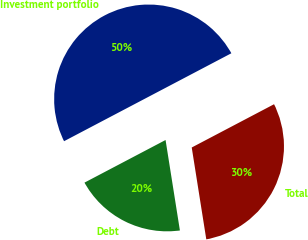Convert chart to OTSL. <chart><loc_0><loc_0><loc_500><loc_500><pie_chart><fcel>Investment portfolio<fcel>Debt<fcel>Total<nl><fcel>50.0%<fcel>19.8%<fcel>30.2%<nl></chart> 